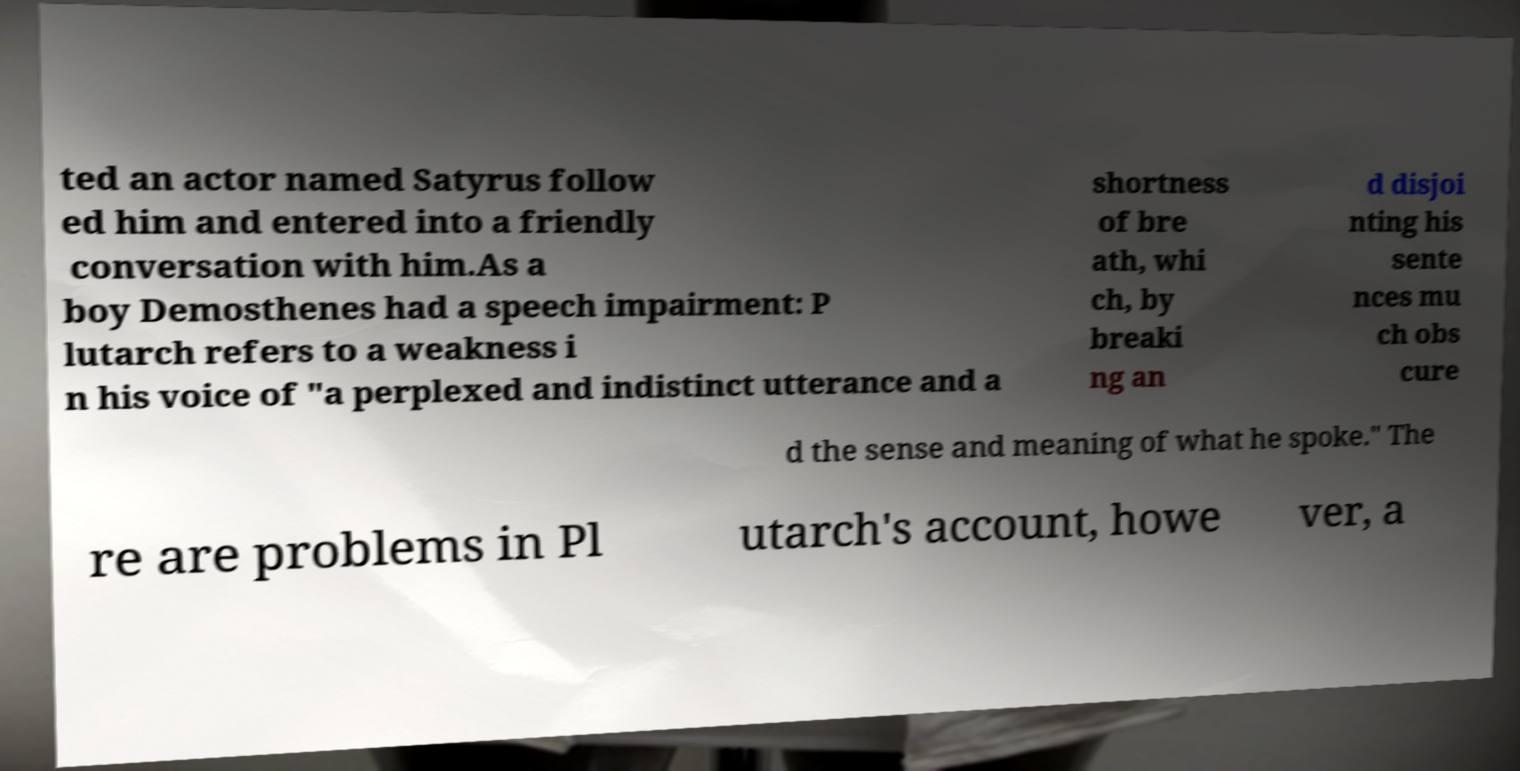I need the written content from this picture converted into text. Can you do that? ted an actor named Satyrus follow ed him and entered into a friendly conversation with him.As a boy Demosthenes had a speech impairment: P lutarch refers to a weakness i n his voice of "a perplexed and indistinct utterance and a shortness of bre ath, whi ch, by breaki ng an d disjoi nting his sente nces mu ch obs cure d the sense and meaning of what he spoke." The re are problems in Pl utarch's account, howe ver, a 